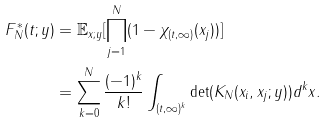Convert formula to latex. <formula><loc_0><loc_0><loc_500><loc_500>F _ { N } ^ { \ast } ( t ; y ) & = \mathbb { E } _ { x ; y } [ \prod _ { j = 1 } ^ { N } ( 1 - \chi _ { ( t , \infty ) } ( x _ { j } ) ) ] \\ & = \sum _ { k = 0 } ^ { N } \frac { ( - 1 ) ^ { k } } { k ! } \int _ { ( t , \infty ) ^ { k } } \det ( K _ { N } ( x _ { i } , x _ { j } ; y ) ) d ^ { k } x .</formula> 